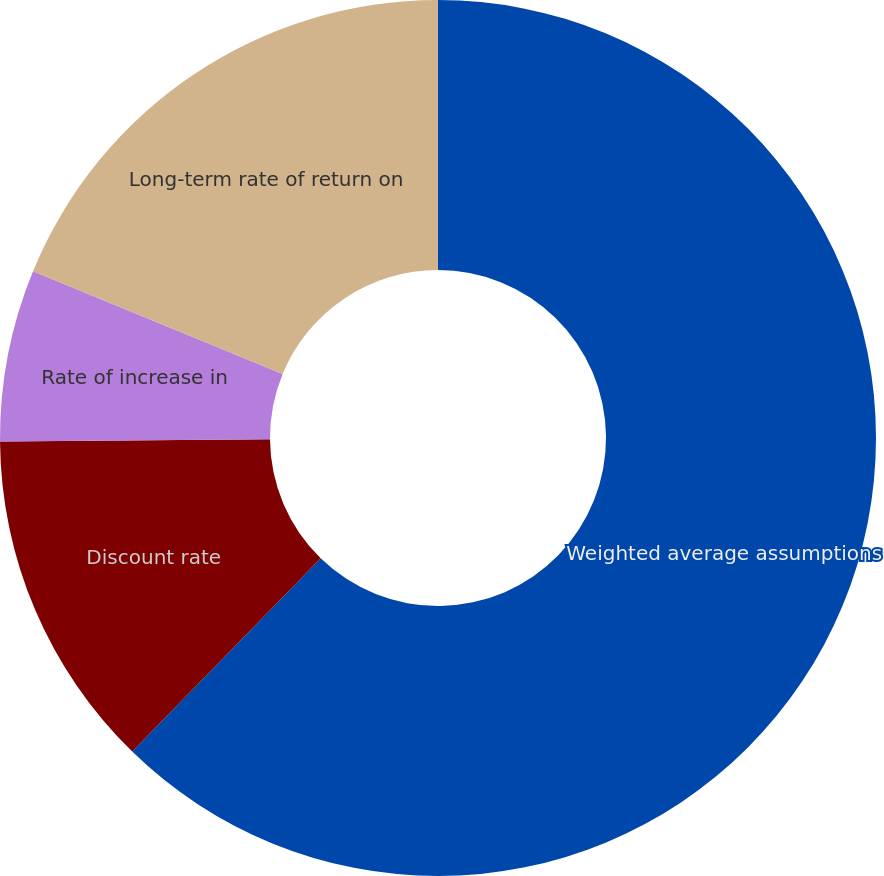<chart> <loc_0><loc_0><loc_500><loc_500><pie_chart><fcel>Weighted average assumptions<fcel>Discount rate<fcel>Rate of increase in<fcel>Long-term rate of return on<nl><fcel>62.3%<fcel>12.57%<fcel>6.35%<fcel>18.78%<nl></chart> 